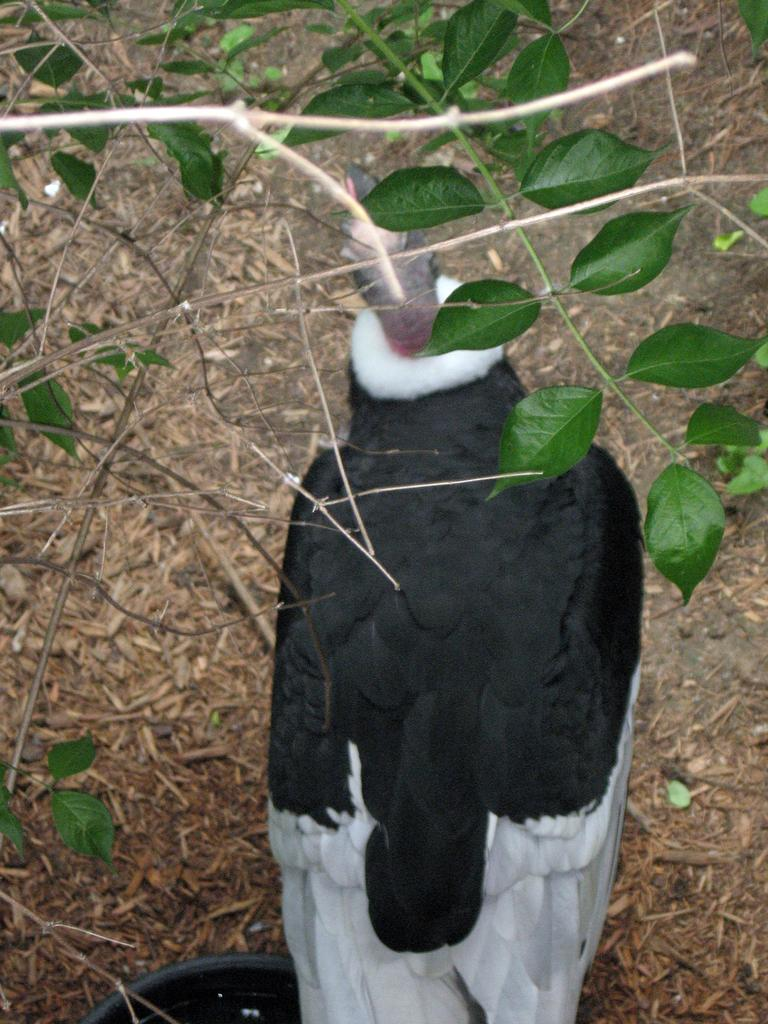What is the main subject in the center of the image? There is a bird in the center of the image. What is located at the bottom of the image? There is ground at the bottom of the image. What type of vegetation is present in the image? There are plants with leaves in the image. What is the profit margin of the loaf of bread in the image? There is no loaf of bread present in the image, so it is not possible to determine the profit margin. 